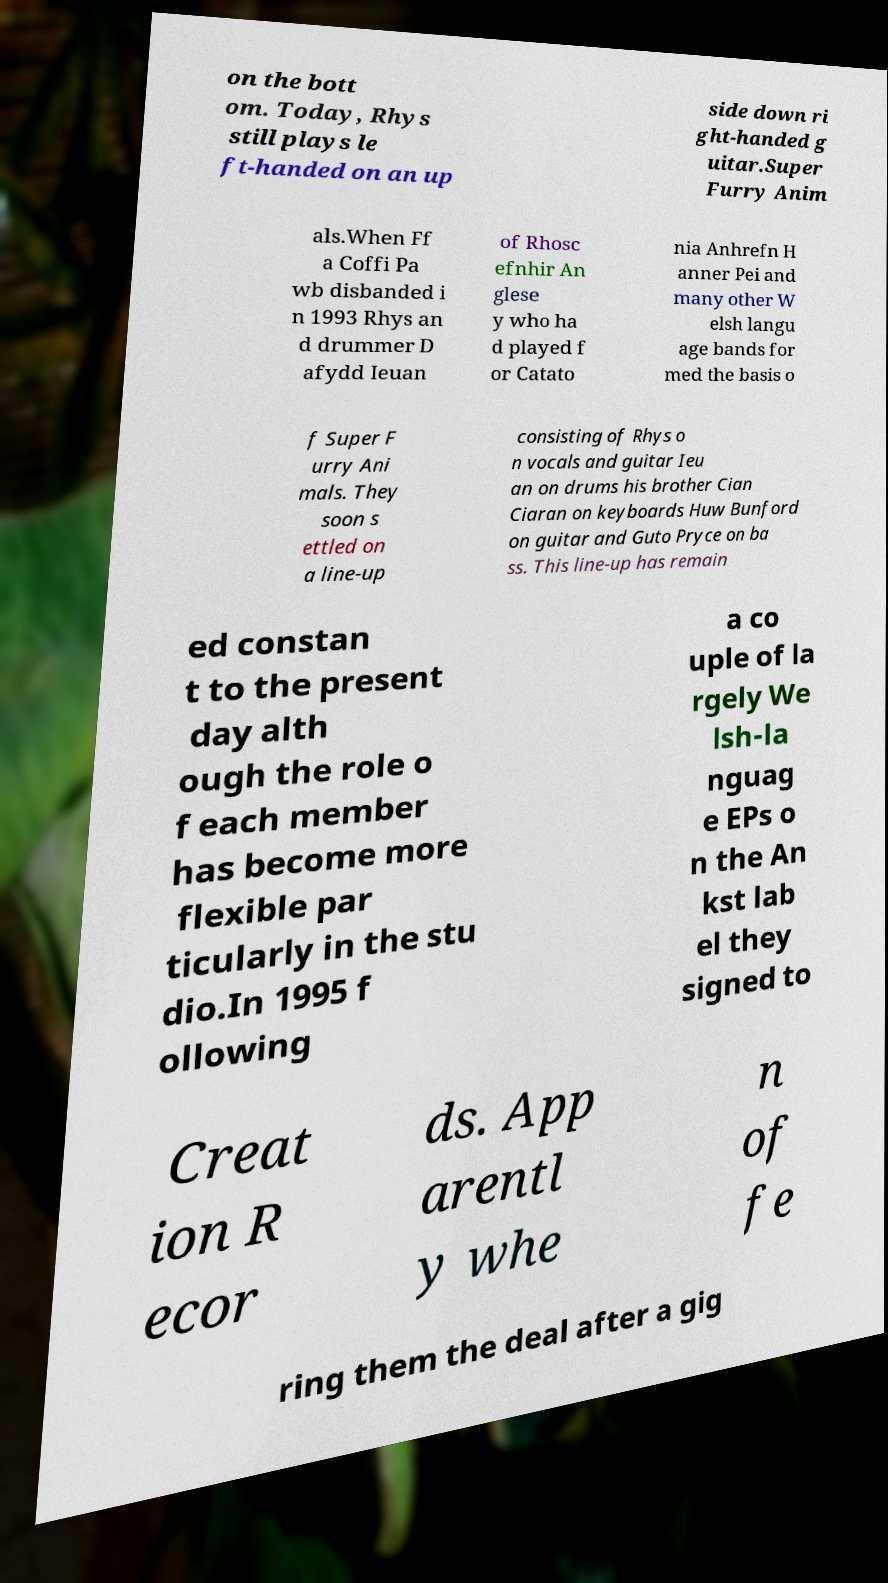For documentation purposes, I need the text within this image transcribed. Could you provide that? on the bott om. Today, Rhys still plays le ft-handed on an up side down ri ght-handed g uitar.Super Furry Anim als.When Ff a Coffi Pa wb disbanded i n 1993 Rhys an d drummer D afydd Ieuan of Rhosc efnhir An glese y who ha d played f or Catato nia Anhrefn H anner Pei and many other W elsh langu age bands for med the basis o f Super F urry Ani mals. They soon s ettled on a line-up consisting of Rhys o n vocals and guitar Ieu an on drums his brother Cian Ciaran on keyboards Huw Bunford on guitar and Guto Pryce on ba ss. This line-up has remain ed constan t to the present day alth ough the role o f each member has become more flexible par ticularly in the stu dio.In 1995 f ollowing a co uple of la rgely We lsh-la nguag e EPs o n the An kst lab el they signed to Creat ion R ecor ds. App arentl y whe n of fe ring them the deal after a gig 